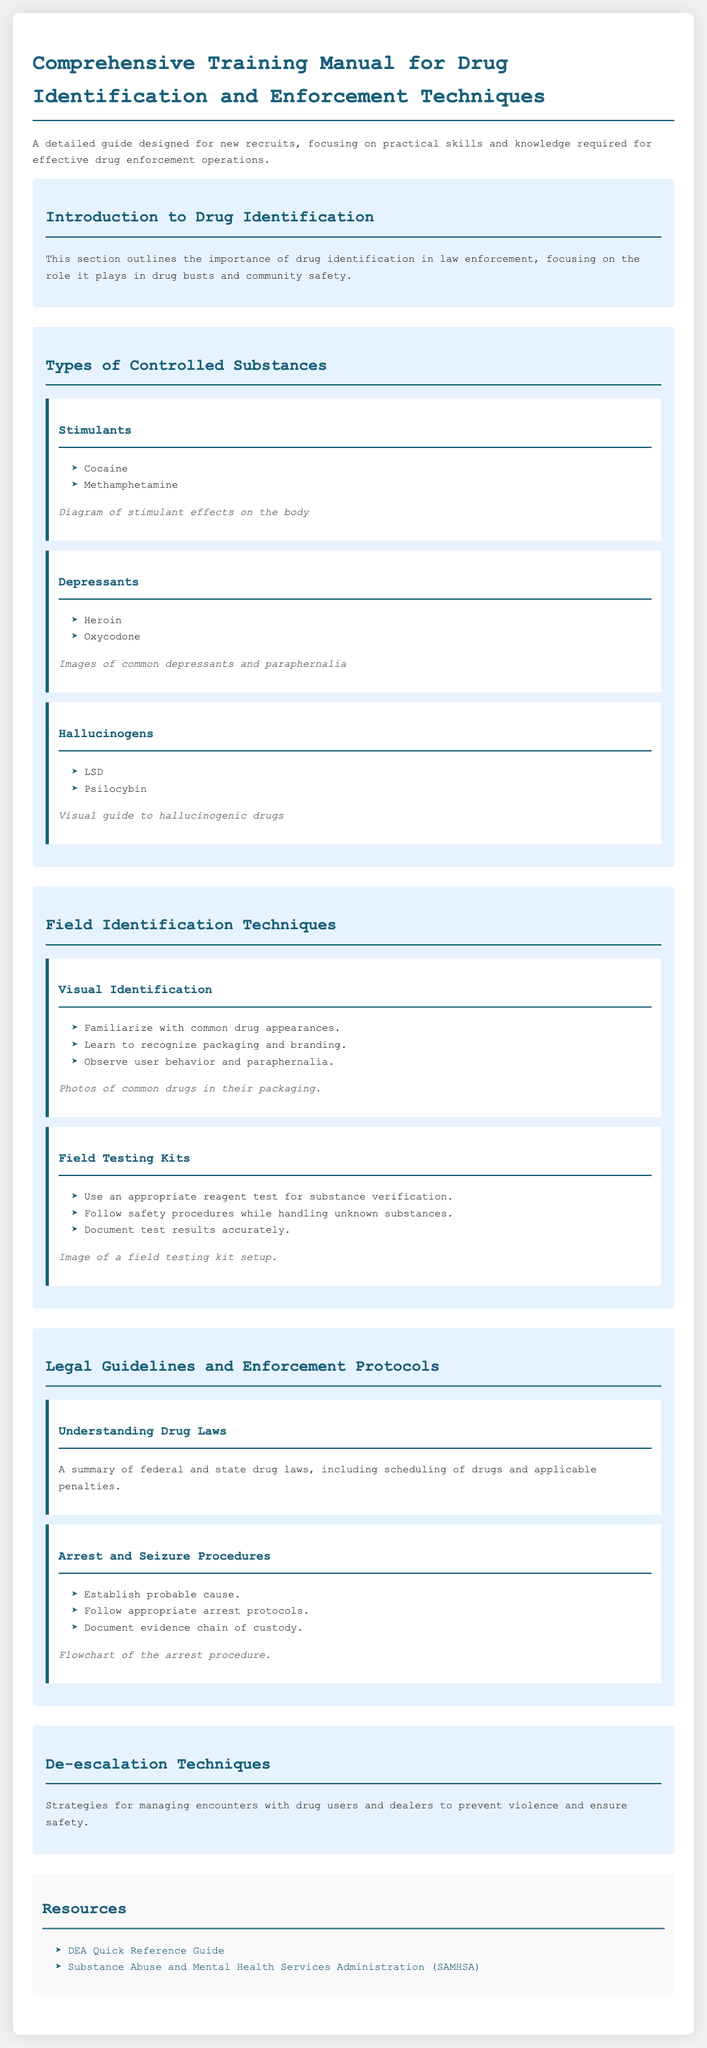what is the title of the document? The title is explicitly stated at the beginning of the document, which is "Comprehensive Training Manual for Drug Identification and Enforcement Techniques."
Answer: Comprehensive Training Manual for Drug Identification and Enforcement Techniques how many types of controlled substances are mentioned? The document lists three main types of controlled substances under a specific section titled "Types of Controlled Substances."
Answer: Three name one stimulant listed in the document. The document provides a list of stimulants under the "Types of Controlled Substances" with examples, including cocaine.
Answer: Cocaine what section discusses legal guidelines? The section focused on legal aspects is titled "Legal Guidelines and Enforcement Protocols."
Answer: Legal Guidelines and Enforcement Protocols what is a required step before making an arrest according to the document? The "Arrest and Seizure Procedures" subsection lists "Establish probable cause" as a crucial step before making an arrest.
Answer: Establish probable cause what visual aid is mentioned in the "Field Testing Kits" subsection? The subsection includes an illustration that describes a field testing kit setup, helping recruits visualize safe handling.
Answer: Image of a field testing kit setup which organization is linked as a resource for substance abuse information? One of the resources provided in the document is a link to the Substance Abuse and Mental Health Services Administration (SAMHSA).
Answer: Substance Abuse and Mental Health Services Administration (SAMHSA) what is the purpose of the "De-escalation Techniques" section? This section outlines strategies for managing encounters to prevent violence and ensure safety.
Answer: Prevent violence and ensure safety 